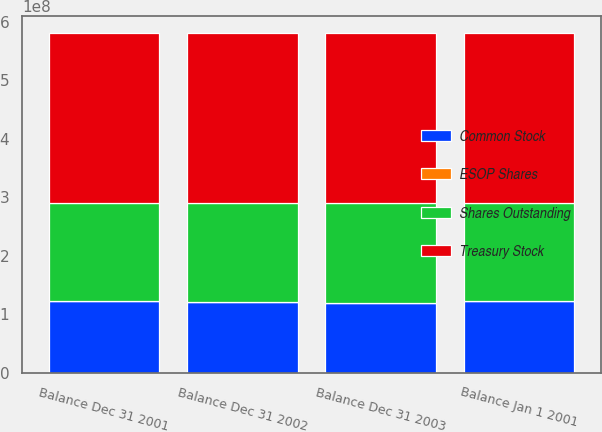Convert chart. <chart><loc_0><loc_0><loc_500><loc_500><stacked_bar_chart><ecel><fcel>Balance Jan 1 2001<fcel>Balance Dec 31 2001<fcel>Balance Dec 31 2002<fcel>Balance Dec 31 2003<nl><fcel>Treasury Stock<fcel>2.90573e+08<fcel>2.90573e+08<fcel>2.90573e+08<fcel>2.90573e+08<nl><fcel>Common Stock<fcel>1.22351e+08<fcel>1.2186e+08<fcel>1.20988e+08<fcel>1.19509e+08<nl><fcel>ESOP Shares<fcel>476<fcel>224958<fcel>142746<fcel>137876<nl><fcel>Shares Outstanding<fcel>1.68222e+08<fcel>1.68488e+08<fcel>1.69442e+08<fcel>1.70927e+08<nl></chart> 